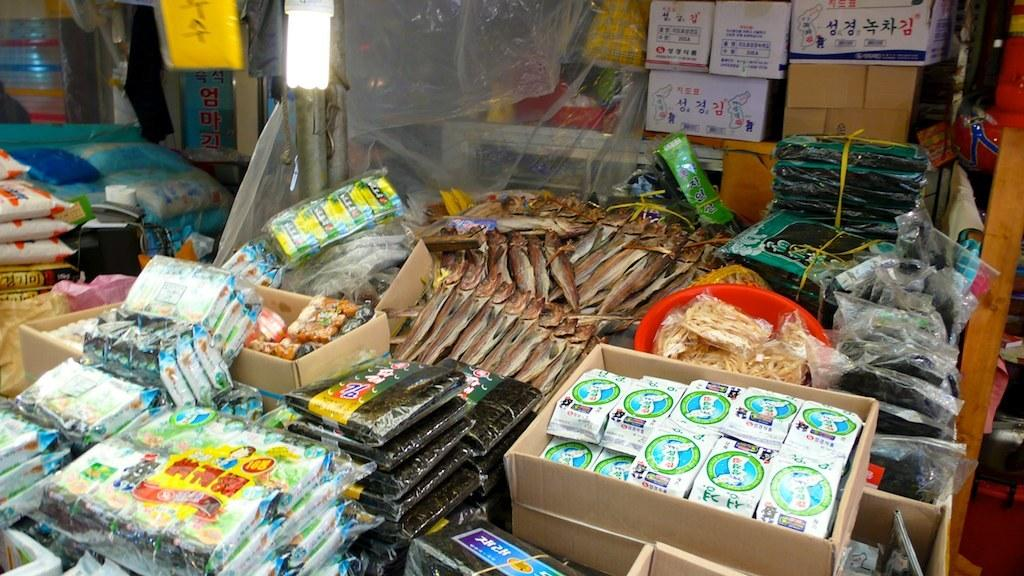What type of containers are present in the image? There are boxes and packets in the image. What living creatures can be seen in the image? There are fishes in the image. What type of items are present in the image? There are food items in the image. What type of storage container is present in the image? There is a basket in the image. What source of light is present in the image? There is a light bulb in the image. Can you describe any other objects in the image? There are other unspecified objects in the image. Can you tell me how many firemen are present in the image? There are no firemen present in the image; it features boxes, packets, fishes, food items, a basket, a light bulb, and other unspecified objects. What symbol of peace can be seen in the image? There is no symbol of peace present in the image; it contains boxes, packets, fishes, food items, a basket, a light bulb, and other unspecified objects. 